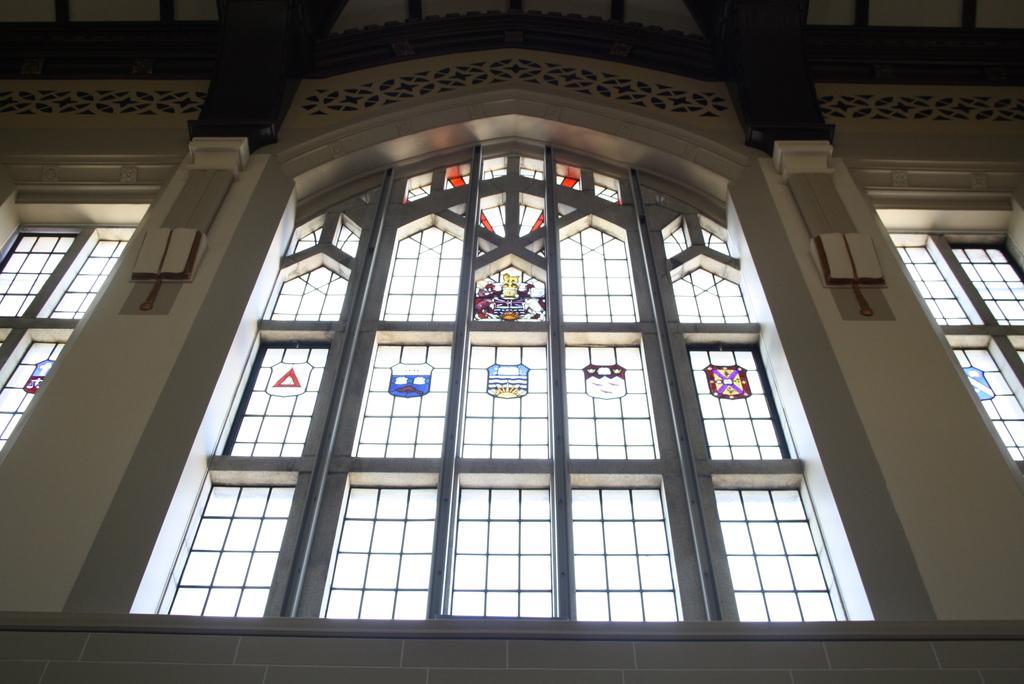How would you summarize this image in a sentence or two? In this image we can see there is an inside view of the building. And there are windows with labels and there is a wall with a design. 